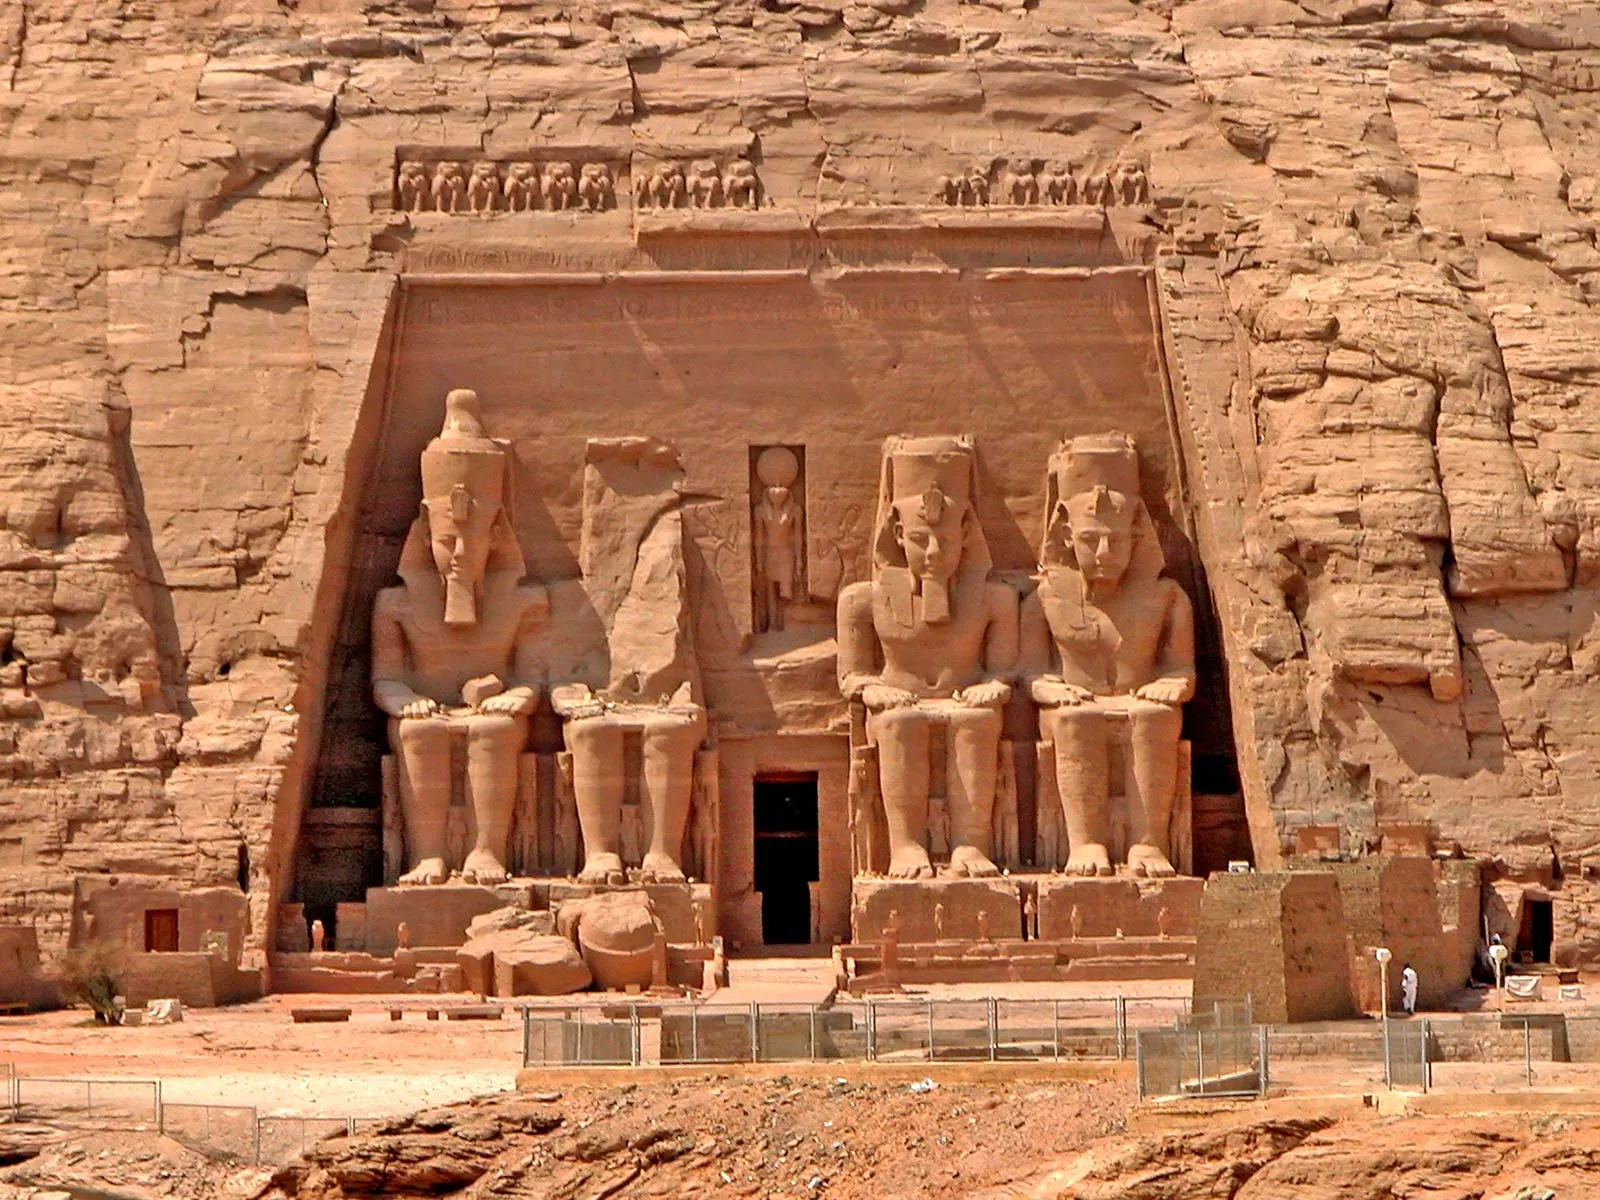If the statues at the temple could speak, what story would they tell about the reign of Ramesses II? If the statues at Abu Simbel could speak, they would tell a tale of a powerful and visionary ruler, Ramesses II, whose reign brought unparalleled prosperity and grandeur to Egypt. They would recount epic battles fought and won, securing Egypt's borders and ensuring peace for its people. The statues would speak of monumental architectural feats, temples, and monuments built under his command, each a testament to his god-like status and divine favor. They would tell of diplomatic prowess, alliances forged through marriage and treaties. The statues would narrate the story of the lavish splendor of the court, the opulence of festivals and religious ceremonies that reinforced the divine right of the pharaoh. They would share insights into the daily life of the era, from the bustling markets filled with exotic goods to the serene beauty of the Nile. Above all, they would sing praises of Ramesses II's enduring legacy, a legacy carved in stone for eternity. 